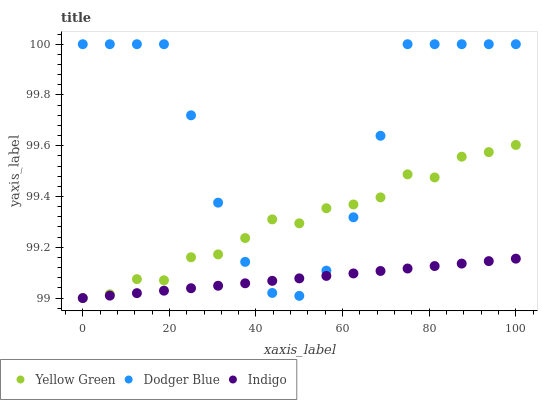Does Indigo have the minimum area under the curve?
Answer yes or no. Yes. Does Dodger Blue have the maximum area under the curve?
Answer yes or no. Yes. Does Yellow Green have the minimum area under the curve?
Answer yes or no. No. Does Yellow Green have the maximum area under the curve?
Answer yes or no. No. Is Indigo the smoothest?
Answer yes or no. Yes. Is Dodger Blue the roughest?
Answer yes or no. Yes. Is Yellow Green the smoothest?
Answer yes or no. No. Is Yellow Green the roughest?
Answer yes or no. No. Does Indigo have the lowest value?
Answer yes or no. Yes. Does Dodger Blue have the lowest value?
Answer yes or no. No. Does Dodger Blue have the highest value?
Answer yes or no. Yes. Does Yellow Green have the highest value?
Answer yes or no. No. Does Yellow Green intersect Indigo?
Answer yes or no. Yes. Is Yellow Green less than Indigo?
Answer yes or no. No. Is Yellow Green greater than Indigo?
Answer yes or no. No. 